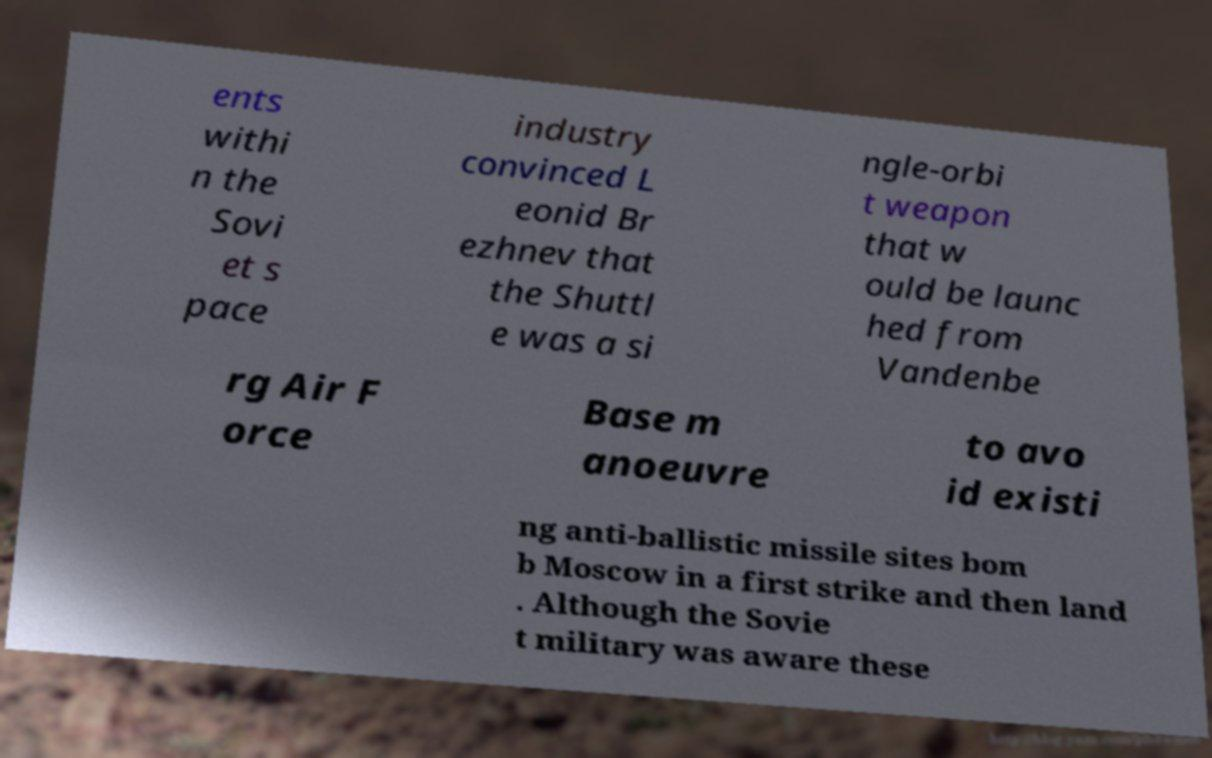Could you assist in decoding the text presented in this image and type it out clearly? ents withi n the Sovi et s pace industry convinced L eonid Br ezhnev that the Shuttl e was a si ngle-orbi t weapon that w ould be launc hed from Vandenbe rg Air F orce Base m anoeuvre to avo id existi ng anti-ballistic missile sites bom b Moscow in a first strike and then land . Although the Sovie t military was aware these 